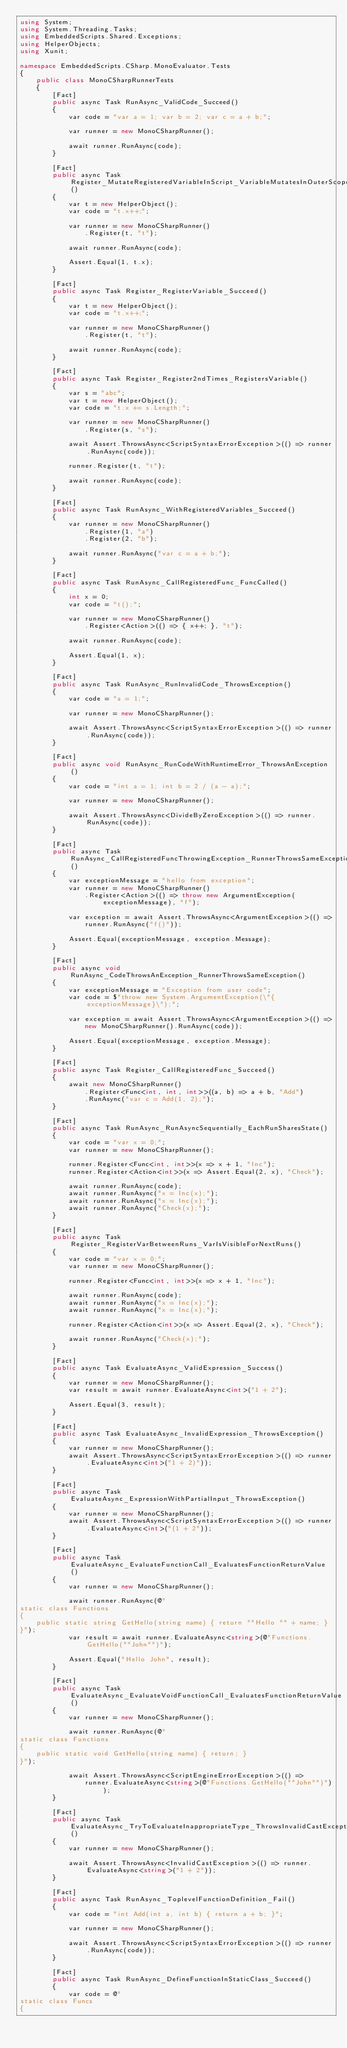<code> <loc_0><loc_0><loc_500><loc_500><_C#_>using System;
using System.Threading.Tasks;
using EmbeddedScripts.Shared.Exceptions;
using HelperObjects;
using Xunit;

namespace EmbeddedScripts.CSharp.MonoEvaluator.Tests
{
    public class MonoCSharpRunnerTests
    {
        [Fact]
        public async Task RunAsync_ValidCode_Succeed()
        {
            var code = "var a = 1; var b = 2; var c = a + b;";

            var runner = new MonoCSharpRunner();

            await runner.RunAsync(code);
        }

        [Fact]
        public async Task Register_MutateRegisteredVariableInScript_VariableMutatesInOuterScope()
        {
            var t = new HelperObject();
            var code = "t.x++;";

            var runner = new MonoCSharpRunner()
                .Register(t, "t");

            await runner.RunAsync(code);

            Assert.Equal(1, t.x);
        }

        [Fact]
        public async Task Register_RegisterVariable_Succeed()
        {
            var t = new HelperObject();
            var code = "t.x++;";

            var runner = new MonoCSharpRunner()
                .Register(t, "t");

            await runner.RunAsync(code);
        }

        [Fact]
        public async Task Register_Register2ndTimes_RegistersVariable()
        {
            var s = "abc";
            var t = new HelperObject();
            var code = "t.x += s.Length;";

            var runner = new MonoCSharpRunner()
                .Register(s, "s");

            await Assert.ThrowsAsync<ScriptSyntaxErrorException>(() => runner.RunAsync(code));

            runner.Register(t, "t");

            await runner.RunAsync(code);
        }

        [Fact]
        public async Task RunAsync_WithRegisteredVariables_Succeed()
        {
            var runner = new MonoCSharpRunner()
                .Register(1, "a")
                .Register(2, "b");

            await runner.RunAsync("var c = a + b;");
        }

        [Fact]
        public async Task RunAsync_CallRegisteredFunc_FuncCalled()
        {
            int x = 0;
            var code = "t();";

            var runner = new MonoCSharpRunner()
                .Register<Action>(() => { x++; }, "t");

            await runner.RunAsync(code);

            Assert.Equal(1, x);
        }

        [Fact]
        public async Task RunAsync_RunInvalidCode_ThrowsException()
        {
            var code = "a = 1;";

            var runner = new MonoCSharpRunner();

            await Assert.ThrowsAsync<ScriptSyntaxErrorException>(() => runner.RunAsync(code));
        }

        [Fact]
        public async void RunAsync_RunCodeWithRuntimeError_ThrowsAnException()
        {
            var code = "int a = 1; int b = 2 / (a - a);";

            var runner = new MonoCSharpRunner();

            await Assert.ThrowsAsync<DivideByZeroException>(() => runner.RunAsync(code));
        }

        [Fact]
        public async Task RunAsync_CallRegisteredFuncThrowingException_RunnerThrowsSameException()
        {
            var exceptionMessage = "hello from exception";
            var runner = new MonoCSharpRunner()
                .Register<Action>(() => throw new ArgumentException(exceptionMessage), "f");

            var exception = await Assert.ThrowsAsync<ArgumentException>(() =>
                runner.RunAsync("f()"));

            Assert.Equal(exceptionMessage, exception.Message);
        }

        [Fact]
        public async void RunAsync_CodeThrowsAnException_RunnerThrowsSameException()
        {
            var exceptionMessage = "Exception from user code";
            var code = $"throw new System.ArgumentException(\"{exceptionMessage}\");";

            var exception = await Assert.ThrowsAsync<ArgumentException>(() =>
                new MonoCSharpRunner().RunAsync(code));

            Assert.Equal(exceptionMessage, exception.Message);
        }

        [Fact]
        public async Task Register_CallRegisteredFunc_Succeed()
        {
            await new MonoCSharpRunner()
                .Register<Func<int, int, int>>((a, b) => a + b, "Add")
                .RunAsync("var c = Add(1, 2);");
        }

        [Fact]
        public async Task RunAsync_RunAsyncSequentially_EachRunSharesState()
        {
            var code = "var x = 0;";
            var runner = new MonoCSharpRunner();

            runner.Register<Func<int, int>>(x => x + 1, "Inc");
            runner.Register<Action<int>>(x => Assert.Equal(2, x), "Check");

            await runner.RunAsync(code);
            await runner.RunAsync("x = Inc(x);");
            await runner.RunAsync("x = Inc(x);");
            await runner.RunAsync("Check(x);");
        }

        [Fact]
        public async Task Register_RegisterVarBetweenRuns_VarIsVisibleForNextRuns()
        {
            var code = "var x = 0;";
            var runner = new MonoCSharpRunner();

            runner.Register<Func<int, int>>(x => x + 1, "Inc");

            await runner.RunAsync(code);
            await runner.RunAsync("x = Inc(x);");
            await runner.RunAsync("x = Inc(x);");

            runner.Register<Action<int>>(x => Assert.Equal(2, x), "Check");

            await runner.RunAsync("Check(x);");
        }

        [Fact]
        public async Task EvaluateAsync_ValidExpression_Success()
        {
            var runner = new MonoCSharpRunner();
            var result = await runner.EvaluateAsync<int>("1 + 2");

            Assert.Equal(3, result);
        }

        [Fact]
        public async Task EvaluateAsync_InvalidExpression_ThrowsException()
        {
            var runner = new MonoCSharpRunner();
            await Assert.ThrowsAsync<ScriptSyntaxErrorException>(() => runner.EvaluateAsync<int>("1 + 2)"));
        }
        
        [Fact]
        public async Task EvaluateAsync_ExpressionWithPartialInput_ThrowsException()
        {
            var runner = new MonoCSharpRunner();
            await Assert.ThrowsAsync<ScriptSyntaxErrorException>(() => runner.EvaluateAsync<int>("(1 + 2"));
        }
        
        [Fact]
        public async Task EvaluateAsync_EvaluateFunctionCall_EvaluatesFunctionReturnValue()
        {
            var runner = new MonoCSharpRunner();

            await runner.RunAsync(@"
static class Functions
{
    public static string GetHello(string name) { return ""Hello "" + name; }
}");
            var result = await runner.EvaluateAsync<string>(@"Functions.GetHello(""John"")");

            Assert.Equal("Hello John", result);
        }

        [Fact]
        public async Task EvaluateAsync_EvaluateVoidFunctionCall_EvaluatesFunctionReturnValue()
        {
            var runner = new MonoCSharpRunner();

            await runner.RunAsync(@"
static class Functions
{
    public static void GetHello(string name) { return; }
}");

            await Assert.ThrowsAsync<ScriptEngineErrorException>(() =>
                runner.EvaluateAsync<string>(@"Functions.GetHello(""John"")"));
        }

        [Fact]
        public async Task EvaluateAsync_TryToEvaluateInappropriateType_ThrowsInvalidCastException()
        {
            var runner = new MonoCSharpRunner();

            await Assert.ThrowsAsync<InvalidCastException>(() => runner.EvaluateAsync<string>("1 + 2"));
        }

        [Fact]
        public async Task RunAsync_ToplevelFunctionDefinition_Fail()
        {
            var code = "int Add(int a, int b) { return a + b; }";

            var runner = new MonoCSharpRunner();

            await Assert.ThrowsAsync<ScriptSyntaxErrorException>(() => runner.RunAsync(code));
        }

        [Fact]
        public async Task RunAsync_DefineFunctionInStaticClass_Succeed()
        {
            var code = @"
static class Funcs 
{ </code> 